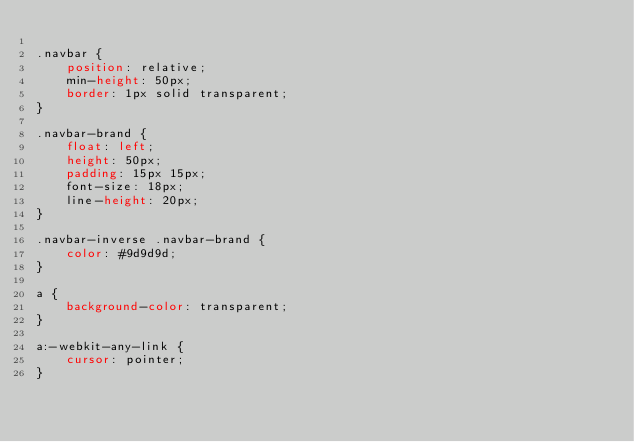<code> <loc_0><loc_0><loc_500><loc_500><_CSS_>
.navbar {
    position: relative;
    min-height: 50px;
    border: 1px solid transparent;
}

.navbar-brand {
    float: left;
    height: 50px;
    padding: 15px 15px;
    font-size: 18px;
    line-height: 20px;
}

.navbar-inverse .navbar-brand {
    color: #9d9d9d;
}

a {
    background-color: transparent;
}

a:-webkit-any-link {
    cursor: pointer;
}</code> 